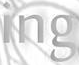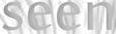Read the text content from these images in order, separated by a semicolon. ing; seen 